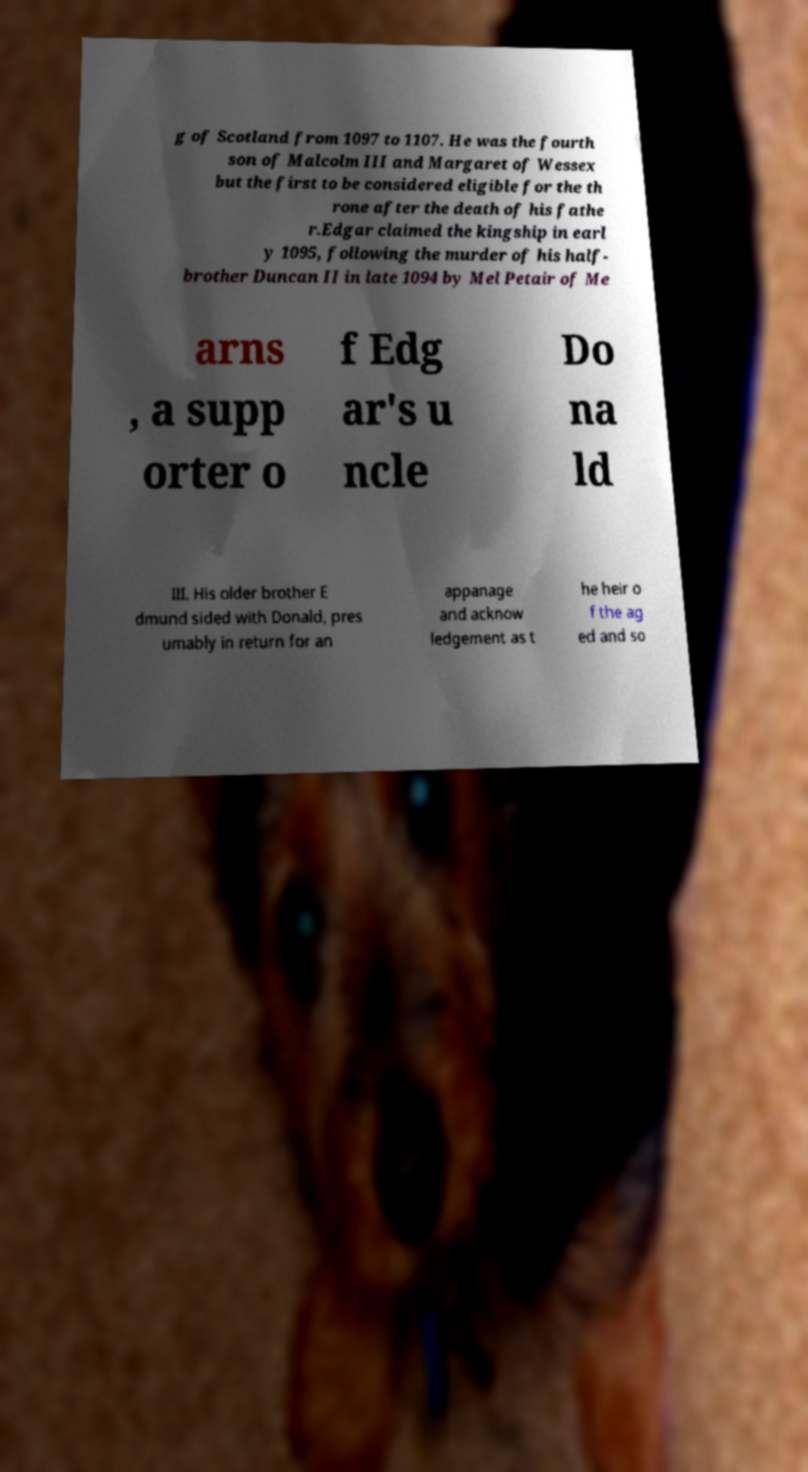I need the written content from this picture converted into text. Can you do that? g of Scotland from 1097 to 1107. He was the fourth son of Malcolm III and Margaret of Wessex but the first to be considered eligible for the th rone after the death of his fathe r.Edgar claimed the kingship in earl y 1095, following the murder of his half- brother Duncan II in late 1094 by Mel Petair of Me arns , a supp orter o f Edg ar's u ncle Do na ld III. His older brother E dmund sided with Donald, pres umably in return for an appanage and acknow ledgement as t he heir o f the ag ed and so 